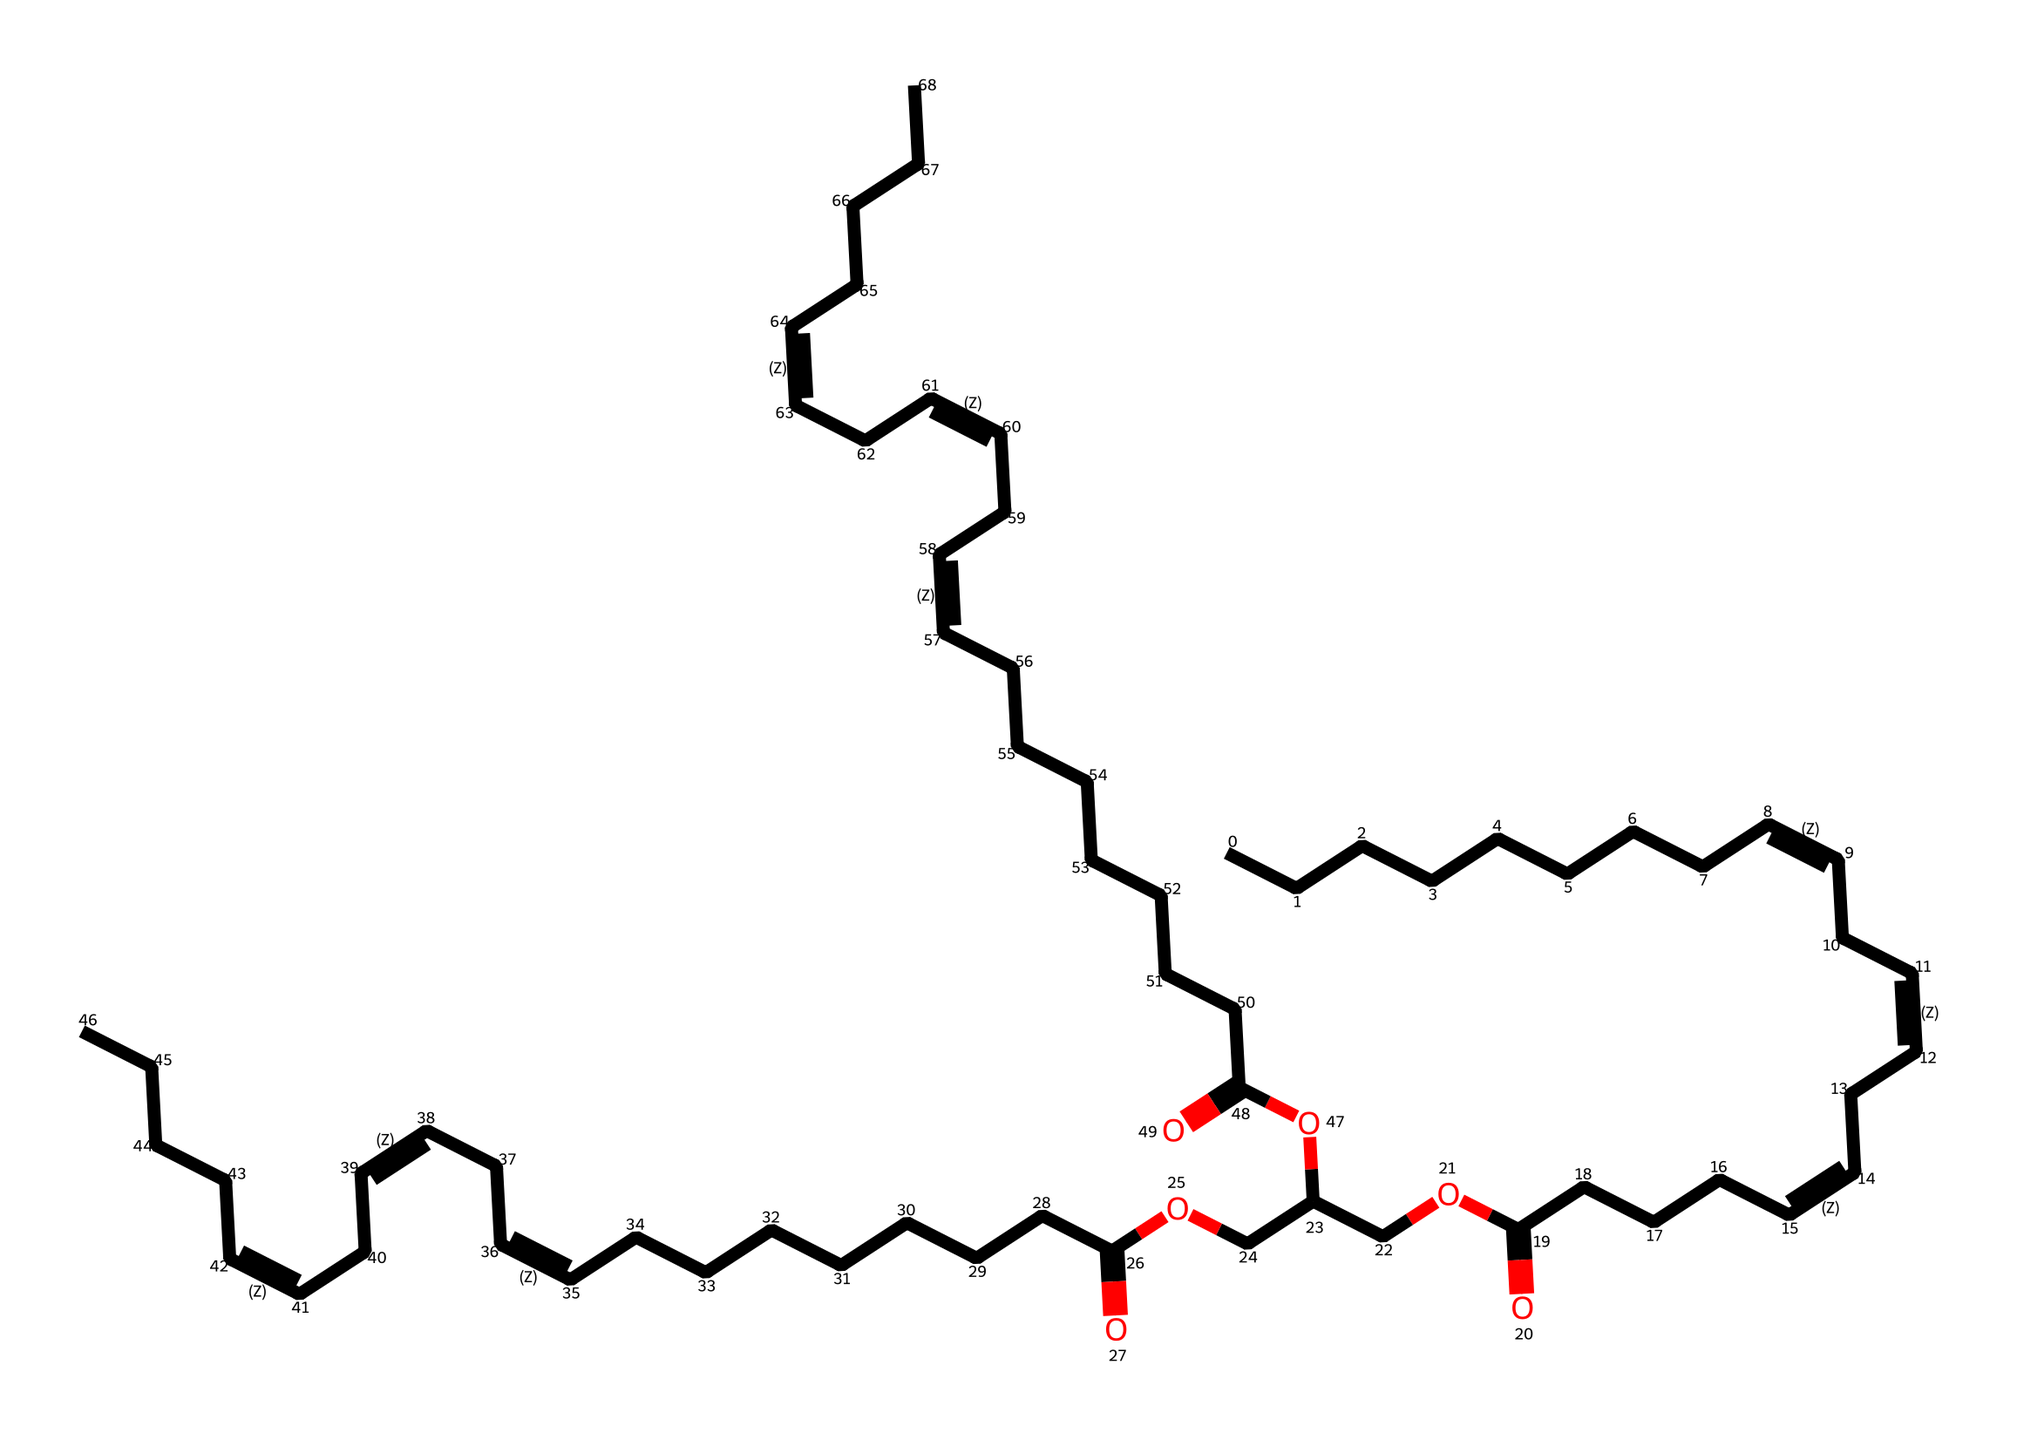What is the main functional group present in linseed oil? The main functional group in linseed oil, as depicted in the SMILES representation, is the carboxylic acid group (-COOH) seen in the structure, which is indicated by the "CCCC(=O)O" part.
Answer: carboxylic acid How many double bonds are present in linseed oil? In the provided SMILES, there are three instances of "/C=C\" representing double bonds. By counting these, we conclude that there are three double bonds in total.
Answer: three What is the longest carbon chain length in linseed oil? By analyzing the repeated "CCCCCCCC" sections within the SMILES notation, we can determine that the longest continuous chain of carbon atoms consists of 18 carbon atoms.
Answer: eighteen What is the molecular nature of linseed oil? The chemical nature, observable through the presence of multiple double bonds and linear carbon chains, indicates that linseed oil is an unsaturated fatty acid ester. This is tied to its aliphatic structure.
Answer: unsaturated fatty acid ester Which type of compound is linseed oil categorized under? The presence of long-chain hydrocarbons and functional groups identifies linseed oil as an aliphatic compound due to its structure comprising primarily of carbon and hydrogen atoms arranged in a linear chain or branched formation.
Answer: aliphatic compound What indicates that linseed oil is a drying oil? The number of double bonds and reactive functional groups in the structure suggests that linseed oil can undergo polymerization upon exposure to air, which is characteristic of drying oils.
Answer: polymerization potential 